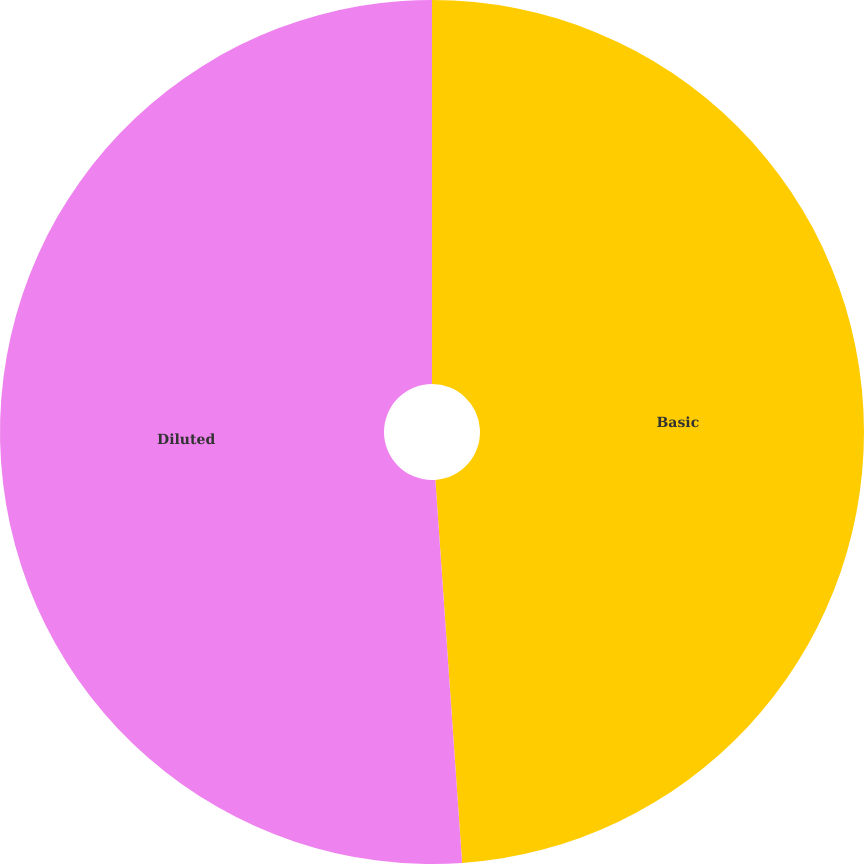Convert chart to OTSL. <chart><loc_0><loc_0><loc_500><loc_500><pie_chart><fcel>Basic<fcel>Diluted<nl><fcel>48.89%<fcel>51.11%<nl></chart> 